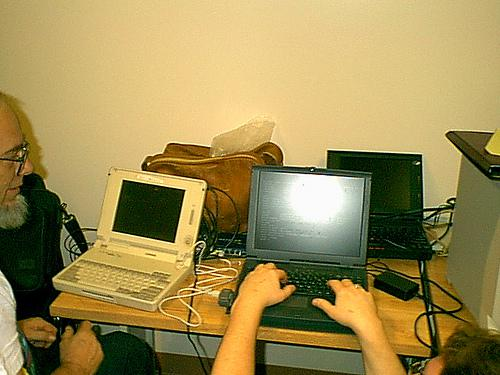Question: what are the color of the laptops?
Choices:
A. Blue and green.
B. Orange and pink.
C. Yellow and red.
D. Black and white.
Answer with the letter. Answer: D Question: what is on the table?
Choices:
A. Flowers.
B. Laptops.
C. Plates.
D. Papers.
Answer with the letter. Answer: B Question: what is the the table made of?
Choices:
A. Plastic.
B. Metal.
C. Wood.
D. Stone.
Answer with the letter. Answer: C Question: who are using the laptop?
Choices:
A. Children.
B. Men.
C. Women.
D. Family.
Answer with the letter. Answer: B Question: when was the laptops used?
Choices:
A. Yesterday.
B. Three days ago.
C. Just now.
D. Several minutes ago.
Answer with the letter. Answer: C Question: how many laptops on the table?
Choices:
A. Three.
B. Four.
C. Five.
D. Two.
Answer with the letter. Answer: A 